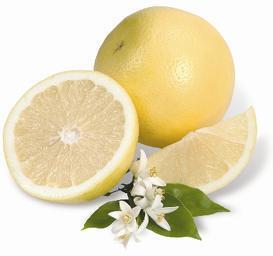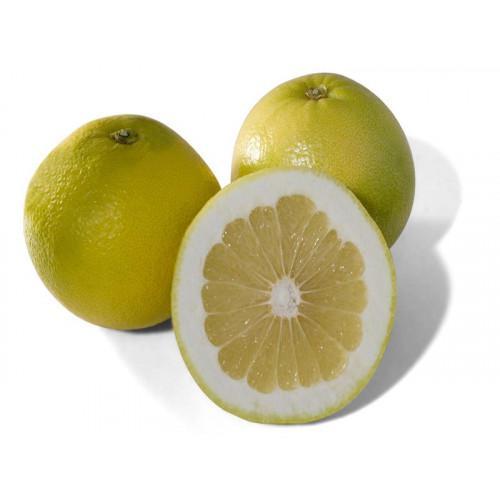The first image is the image on the left, the second image is the image on the right. For the images shown, is this caption "No leaves are visible in the pictures on the right." true? Answer yes or no. Yes. 